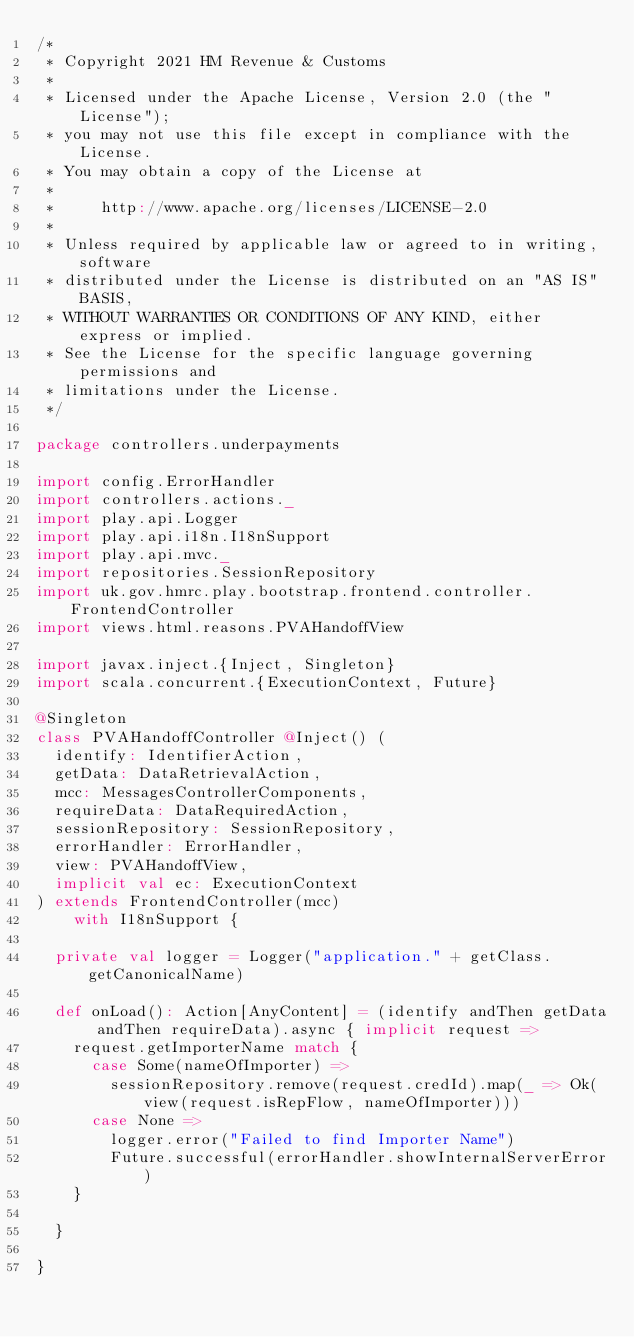<code> <loc_0><loc_0><loc_500><loc_500><_Scala_>/*
 * Copyright 2021 HM Revenue & Customs
 *
 * Licensed under the Apache License, Version 2.0 (the "License");
 * you may not use this file except in compliance with the License.
 * You may obtain a copy of the License at
 *
 *     http://www.apache.org/licenses/LICENSE-2.0
 *
 * Unless required by applicable law or agreed to in writing, software
 * distributed under the License is distributed on an "AS IS" BASIS,
 * WITHOUT WARRANTIES OR CONDITIONS OF ANY KIND, either express or implied.
 * See the License for the specific language governing permissions and
 * limitations under the License.
 */

package controllers.underpayments

import config.ErrorHandler
import controllers.actions._
import play.api.Logger
import play.api.i18n.I18nSupport
import play.api.mvc._
import repositories.SessionRepository
import uk.gov.hmrc.play.bootstrap.frontend.controller.FrontendController
import views.html.reasons.PVAHandoffView

import javax.inject.{Inject, Singleton}
import scala.concurrent.{ExecutionContext, Future}

@Singleton
class PVAHandoffController @Inject() (
  identify: IdentifierAction,
  getData: DataRetrievalAction,
  mcc: MessagesControllerComponents,
  requireData: DataRequiredAction,
  sessionRepository: SessionRepository,
  errorHandler: ErrorHandler,
  view: PVAHandoffView,
  implicit val ec: ExecutionContext
) extends FrontendController(mcc)
    with I18nSupport {

  private val logger = Logger("application." + getClass.getCanonicalName)

  def onLoad(): Action[AnyContent] = (identify andThen getData andThen requireData).async { implicit request =>
    request.getImporterName match {
      case Some(nameOfImporter) =>
        sessionRepository.remove(request.credId).map(_ => Ok(view(request.isRepFlow, nameOfImporter)))
      case None =>
        logger.error("Failed to find Importer Name")
        Future.successful(errorHandler.showInternalServerError)
    }

  }

}
</code> 